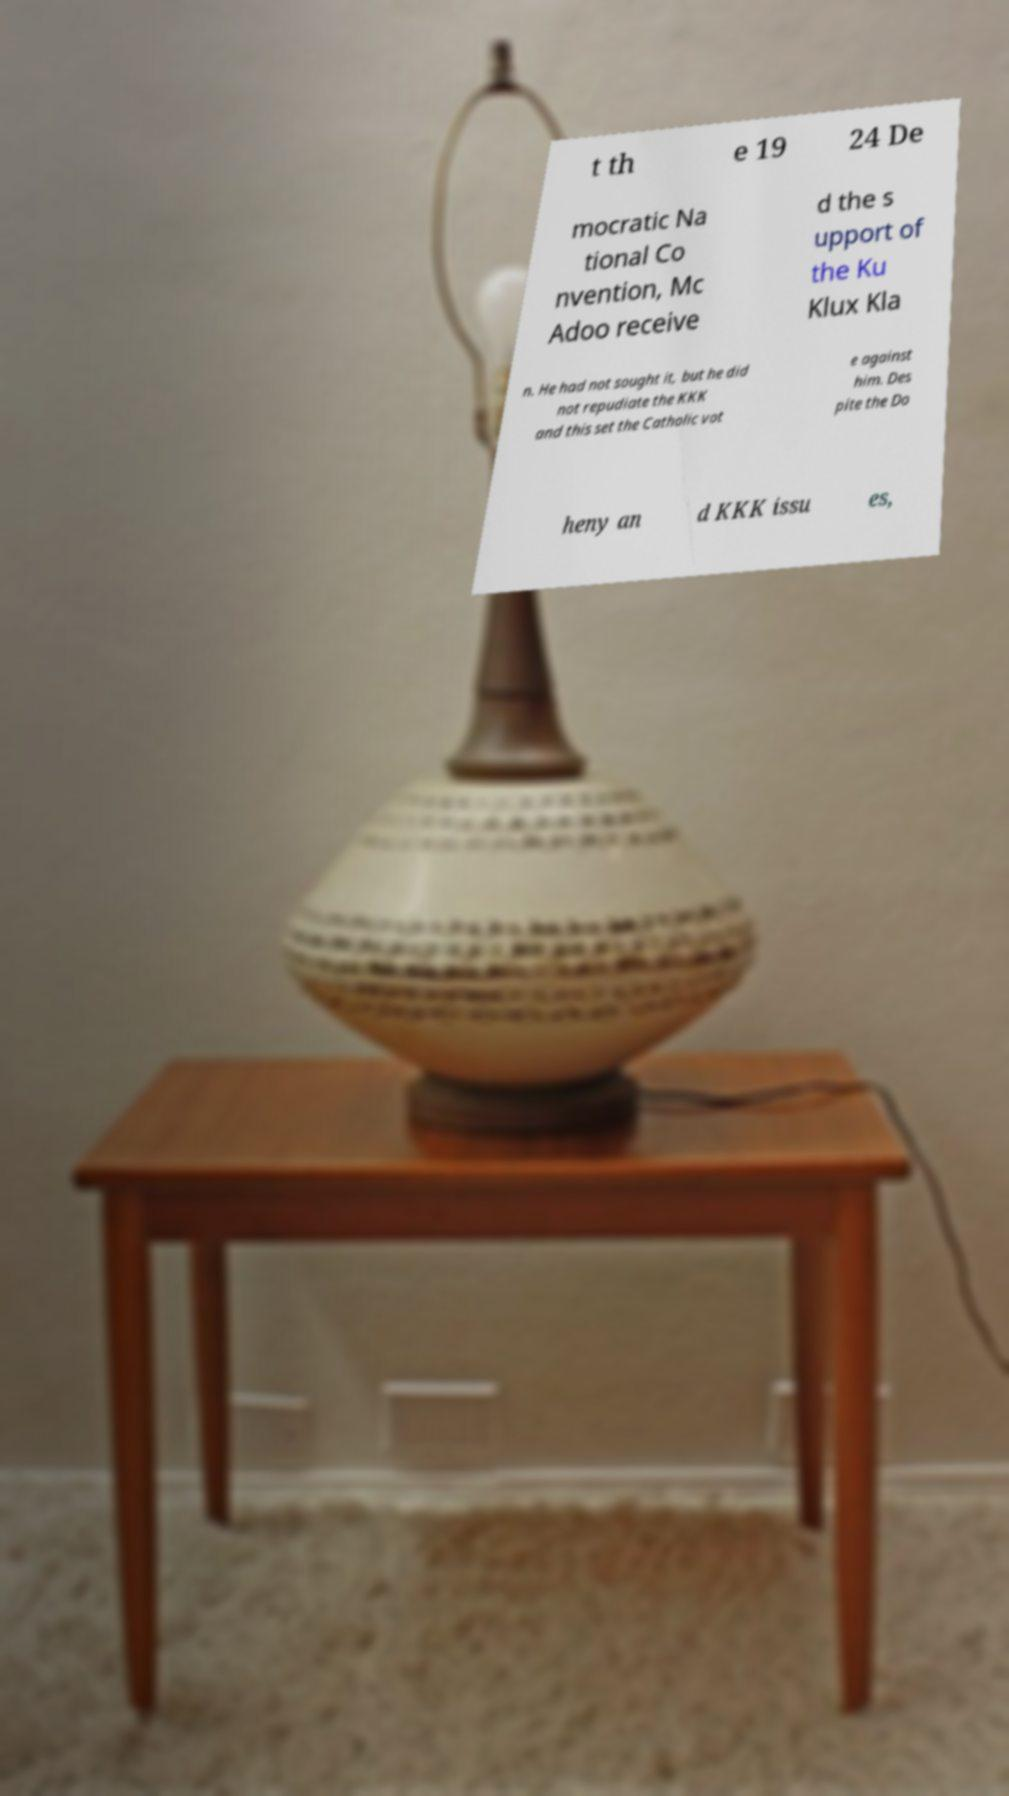Could you assist in decoding the text presented in this image and type it out clearly? t th e 19 24 De mocratic Na tional Co nvention, Mc Adoo receive d the s upport of the Ku Klux Kla n. He had not sought it, but he did not repudiate the KKK and this set the Catholic vot e against him. Des pite the Do heny an d KKK issu es, 